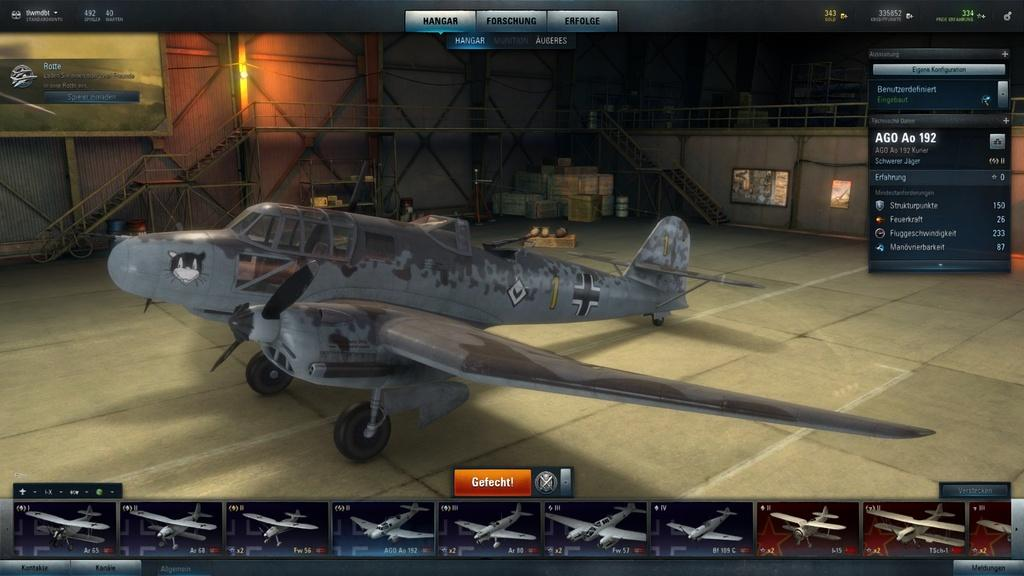<image>
Provide a brief description of the given image. a game about planes with a orange button with Gefecht on it 